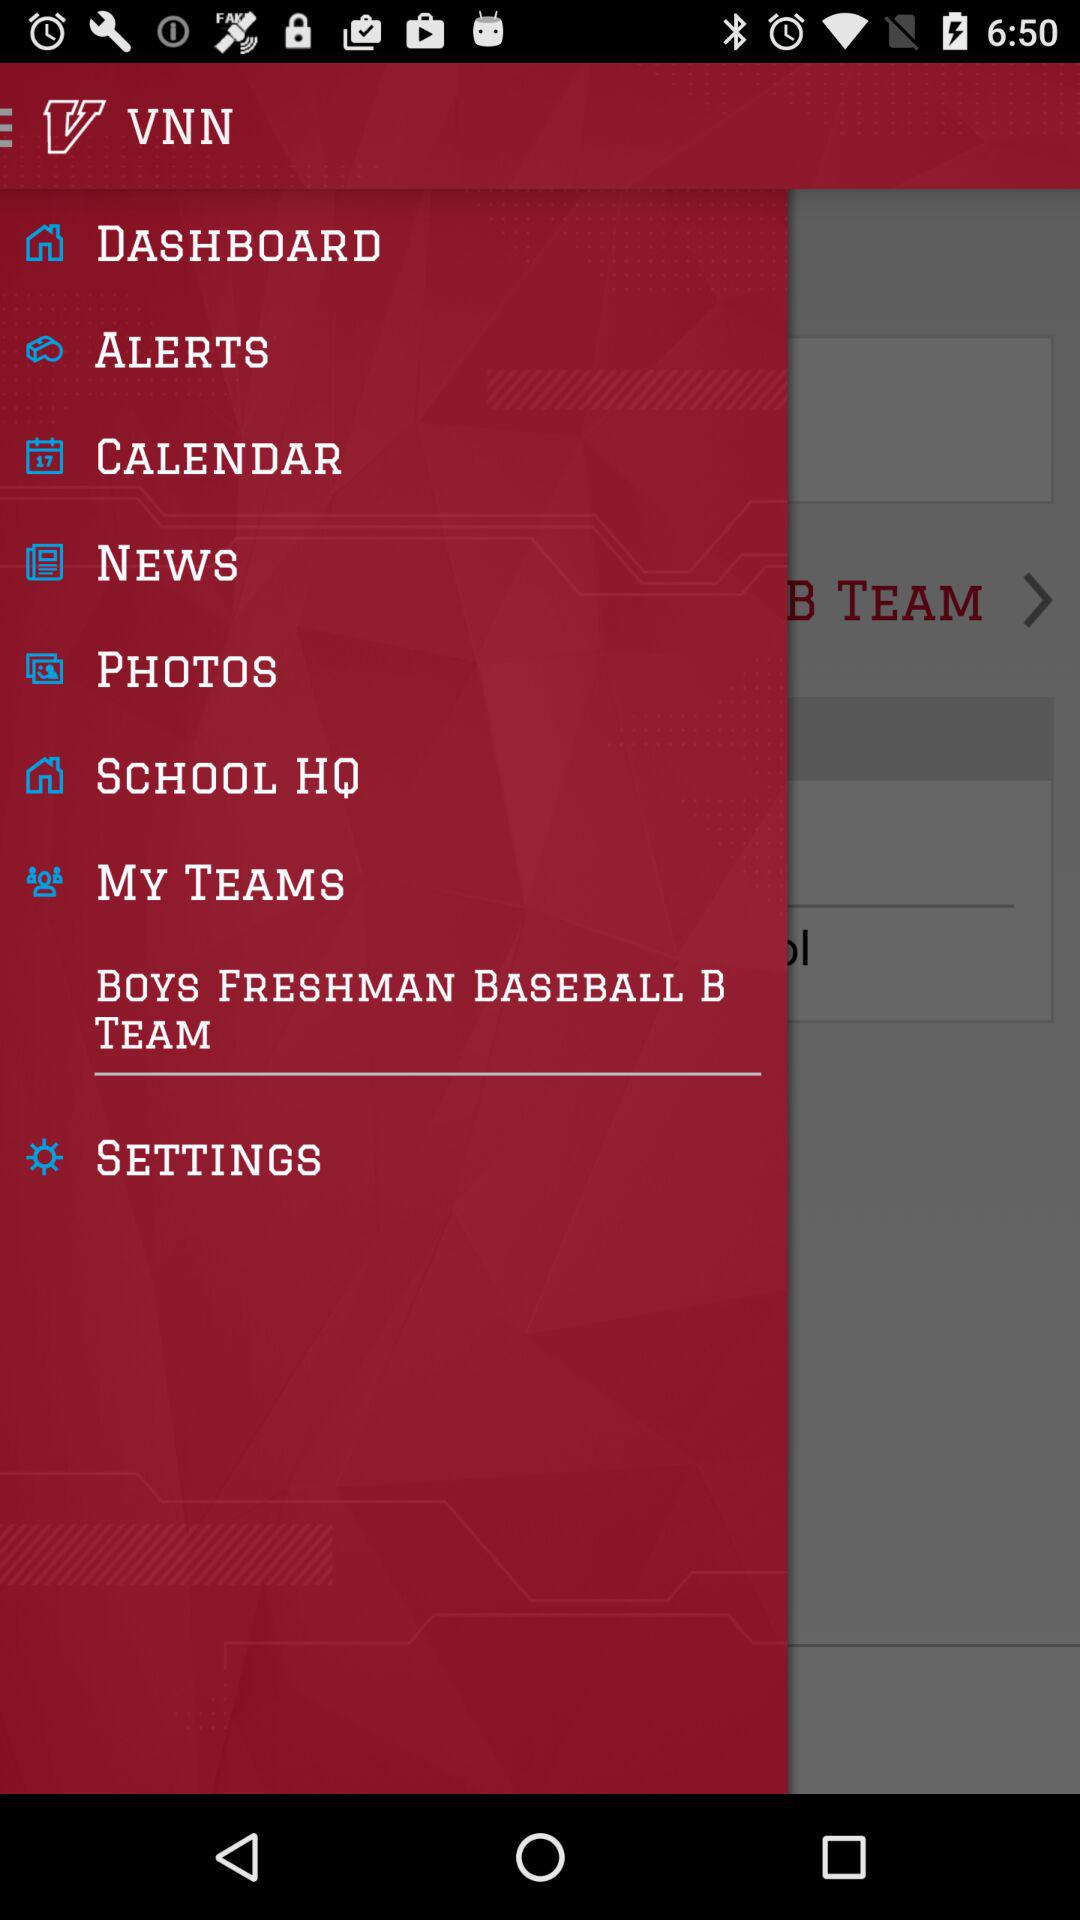When does the season begin and end?
When the provided information is insufficient, respond with <no answer>. <no answer> 